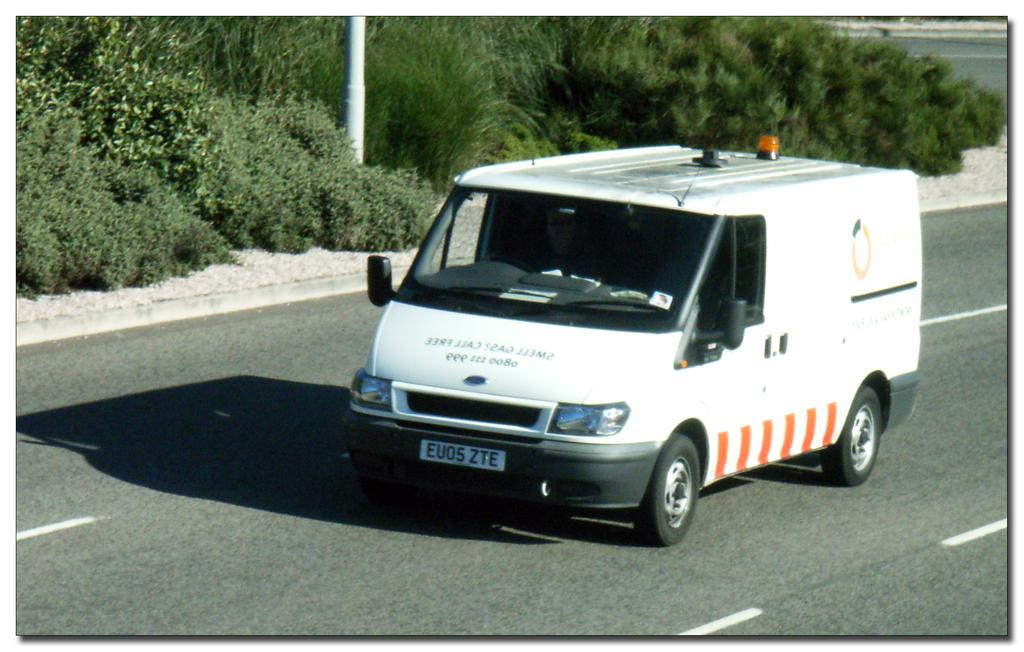Provide a one-sentence caption for the provided image. A white van drives down the road with a license plate displaying the characters EVOS ZTE. 